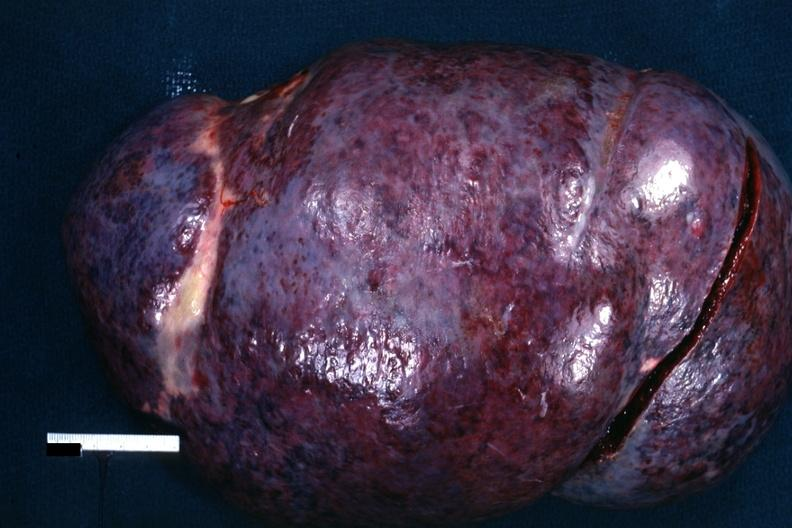does this image show external view of massively enlarged spleen with purple color?
Answer the question using a single word or phrase. Yes 